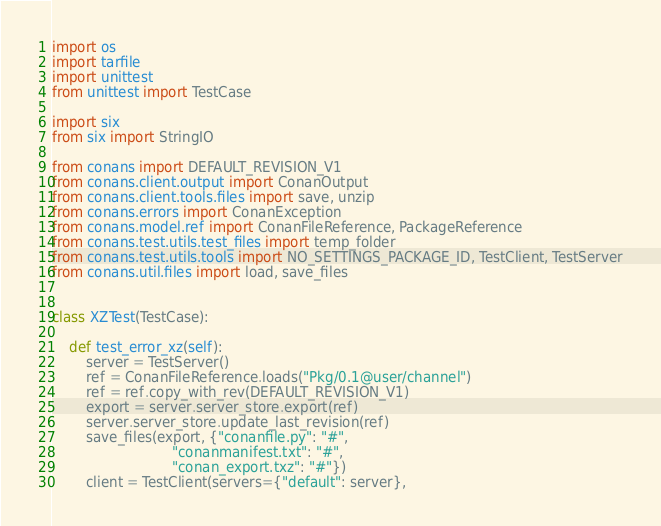Convert code to text. <code><loc_0><loc_0><loc_500><loc_500><_Python_>import os
import tarfile
import unittest
from unittest import TestCase

import six
from six import StringIO

from conans import DEFAULT_REVISION_V1
from conans.client.output import ConanOutput
from conans.client.tools.files import save, unzip
from conans.errors import ConanException
from conans.model.ref import ConanFileReference, PackageReference
from conans.test.utils.test_files import temp_folder
from conans.test.utils.tools import NO_SETTINGS_PACKAGE_ID, TestClient, TestServer
from conans.util.files import load, save_files


class XZTest(TestCase):

    def test_error_xz(self):
        server = TestServer()
        ref = ConanFileReference.loads("Pkg/0.1@user/channel")
        ref = ref.copy_with_rev(DEFAULT_REVISION_V1)
        export = server.server_store.export(ref)
        server.server_store.update_last_revision(ref)
        save_files(export, {"conanfile.py": "#",
                            "conanmanifest.txt": "#",
                            "conan_export.txz": "#"})
        client = TestClient(servers={"default": server},</code> 